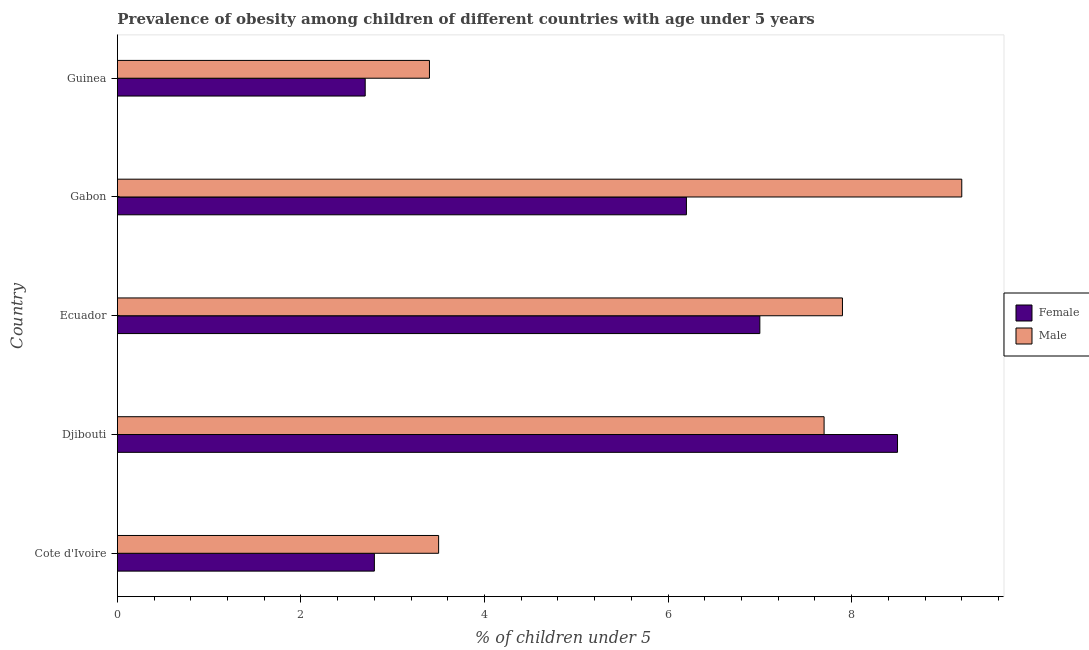How many groups of bars are there?
Give a very brief answer. 5. Are the number of bars on each tick of the Y-axis equal?
Offer a terse response. Yes. What is the label of the 1st group of bars from the top?
Provide a succinct answer. Guinea. In how many cases, is the number of bars for a given country not equal to the number of legend labels?
Your response must be concise. 0. What is the percentage of obese male children in Cote d'Ivoire?
Give a very brief answer. 3.5. Across all countries, what is the maximum percentage of obese male children?
Provide a short and direct response. 9.2. Across all countries, what is the minimum percentage of obese female children?
Offer a terse response. 2.7. In which country was the percentage of obese female children maximum?
Your answer should be compact. Djibouti. In which country was the percentage of obese male children minimum?
Make the answer very short. Guinea. What is the total percentage of obese female children in the graph?
Offer a terse response. 27.2. What is the difference between the percentage of obese male children in Guinea and the percentage of obese female children in Djibouti?
Offer a terse response. -5.1. What is the average percentage of obese male children per country?
Provide a succinct answer. 6.34. What is the difference between the percentage of obese male children and percentage of obese female children in Gabon?
Your response must be concise. 3. In how many countries, is the percentage of obese male children greater than 4.4 %?
Your response must be concise. 3. What is the ratio of the percentage of obese male children in Ecuador to that in Gabon?
Keep it short and to the point. 0.86. Is the percentage of obese female children in Cote d'Ivoire less than that in Djibouti?
Your answer should be compact. Yes. Is the difference between the percentage of obese female children in Djibouti and Gabon greater than the difference between the percentage of obese male children in Djibouti and Gabon?
Give a very brief answer. Yes. What is the difference between the highest and the second highest percentage of obese male children?
Your answer should be compact. 1.3. What is the difference between the highest and the lowest percentage of obese male children?
Provide a succinct answer. 5.8. In how many countries, is the percentage of obese male children greater than the average percentage of obese male children taken over all countries?
Ensure brevity in your answer.  3. Is the sum of the percentage of obese male children in Ecuador and Guinea greater than the maximum percentage of obese female children across all countries?
Offer a very short reply. Yes. What does the 2nd bar from the top in Djibouti represents?
Give a very brief answer. Female. How many bars are there?
Keep it short and to the point. 10. Are all the bars in the graph horizontal?
Offer a terse response. Yes. How many countries are there in the graph?
Offer a very short reply. 5. What is the difference between two consecutive major ticks on the X-axis?
Your answer should be very brief. 2. Does the graph contain grids?
Make the answer very short. No. How are the legend labels stacked?
Offer a very short reply. Vertical. What is the title of the graph?
Ensure brevity in your answer.  Prevalence of obesity among children of different countries with age under 5 years. What is the label or title of the X-axis?
Ensure brevity in your answer.   % of children under 5. What is the label or title of the Y-axis?
Give a very brief answer. Country. What is the  % of children under 5 of Female in Cote d'Ivoire?
Give a very brief answer. 2.8. What is the  % of children under 5 in Male in Cote d'Ivoire?
Keep it short and to the point. 3.5. What is the  % of children under 5 in Female in Djibouti?
Keep it short and to the point. 8.5. What is the  % of children under 5 of Male in Djibouti?
Your answer should be very brief. 7.7. What is the  % of children under 5 in Female in Ecuador?
Ensure brevity in your answer.  7. What is the  % of children under 5 in Male in Ecuador?
Give a very brief answer. 7.9. What is the  % of children under 5 in Female in Gabon?
Your answer should be very brief. 6.2. What is the  % of children under 5 in Male in Gabon?
Make the answer very short. 9.2. What is the  % of children under 5 in Female in Guinea?
Your answer should be compact. 2.7. What is the  % of children under 5 in Male in Guinea?
Offer a very short reply. 3.4. Across all countries, what is the maximum  % of children under 5 of Female?
Offer a very short reply. 8.5. Across all countries, what is the maximum  % of children under 5 in Male?
Give a very brief answer. 9.2. Across all countries, what is the minimum  % of children under 5 in Female?
Provide a short and direct response. 2.7. Across all countries, what is the minimum  % of children under 5 of Male?
Your response must be concise. 3.4. What is the total  % of children under 5 of Female in the graph?
Keep it short and to the point. 27.2. What is the total  % of children under 5 of Male in the graph?
Provide a succinct answer. 31.7. What is the difference between the  % of children under 5 of Female in Cote d'Ivoire and that in Djibouti?
Offer a very short reply. -5.7. What is the difference between the  % of children under 5 of Female in Cote d'Ivoire and that in Ecuador?
Your answer should be compact. -4.2. What is the difference between the  % of children under 5 of Male in Cote d'Ivoire and that in Ecuador?
Provide a short and direct response. -4.4. What is the difference between the  % of children under 5 of Female in Cote d'Ivoire and that in Gabon?
Ensure brevity in your answer.  -3.4. What is the difference between the  % of children under 5 of Male in Cote d'Ivoire and that in Gabon?
Give a very brief answer. -5.7. What is the difference between the  % of children under 5 in Female in Djibouti and that in Ecuador?
Offer a very short reply. 1.5. What is the difference between the  % of children under 5 of Male in Djibouti and that in Gabon?
Provide a succinct answer. -1.5. What is the difference between the  % of children under 5 of Male in Djibouti and that in Guinea?
Offer a very short reply. 4.3. What is the difference between the  % of children under 5 in Female in Ecuador and that in Gabon?
Ensure brevity in your answer.  0.8. What is the difference between the  % of children under 5 of Female in Ecuador and that in Guinea?
Your answer should be compact. 4.3. What is the difference between the  % of children under 5 in Female in Gabon and that in Guinea?
Your answer should be very brief. 3.5. What is the difference between the  % of children under 5 of Male in Gabon and that in Guinea?
Provide a succinct answer. 5.8. What is the difference between the  % of children under 5 in Female in Djibouti and the  % of children under 5 in Male in Ecuador?
Offer a very short reply. 0.6. What is the difference between the  % of children under 5 of Female in Djibouti and the  % of children under 5 of Male in Guinea?
Ensure brevity in your answer.  5.1. What is the average  % of children under 5 of Female per country?
Ensure brevity in your answer.  5.44. What is the average  % of children under 5 in Male per country?
Offer a very short reply. 6.34. What is the difference between the  % of children under 5 of Female and  % of children under 5 of Male in Djibouti?
Offer a terse response. 0.8. What is the difference between the  % of children under 5 of Female and  % of children under 5 of Male in Ecuador?
Offer a terse response. -0.9. What is the difference between the  % of children under 5 in Female and  % of children under 5 in Male in Gabon?
Provide a succinct answer. -3. What is the ratio of the  % of children under 5 in Female in Cote d'Ivoire to that in Djibouti?
Offer a very short reply. 0.33. What is the ratio of the  % of children under 5 of Male in Cote d'Ivoire to that in Djibouti?
Your response must be concise. 0.45. What is the ratio of the  % of children under 5 of Male in Cote d'Ivoire to that in Ecuador?
Give a very brief answer. 0.44. What is the ratio of the  % of children under 5 of Female in Cote d'Ivoire to that in Gabon?
Keep it short and to the point. 0.45. What is the ratio of the  % of children under 5 of Male in Cote d'Ivoire to that in Gabon?
Offer a very short reply. 0.38. What is the ratio of the  % of children under 5 in Male in Cote d'Ivoire to that in Guinea?
Your response must be concise. 1.03. What is the ratio of the  % of children under 5 of Female in Djibouti to that in Ecuador?
Provide a short and direct response. 1.21. What is the ratio of the  % of children under 5 of Male in Djibouti to that in Ecuador?
Give a very brief answer. 0.97. What is the ratio of the  % of children under 5 of Female in Djibouti to that in Gabon?
Keep it short and to the point. 1.37. What is the ratio of the  % of children under 5 of Male in Djibouti to that in Gabon?
Keep it short and to the point. 0.84. What is the ratio of the  % of children under 5 in Female in Djibouti to that in Guinea?
Ensure brevity in your answer.  3.15. What is the ratio of the  % of children under 5 of Male in Djibouti to that in Guinea?
Ensure brevity in your answer.  2.26. What is the ratio of the  % of children under 5 of Female in Ecuador to that in Gabon?
Ensure brevity in your answer.  1.13. What is the ratio of the  % of children under 5 in Male in Ecuador to that in Gabon?
Provide a succinct answer. 0.86. What is the ratio of the  % of children under 5 of Female in Ecuador to that in Guinea?
Make the answer very short. 2.59. What is the ratio of the  % of children under 5 of Male in Ecuador to that in Guinea?
Your answer should be very brief. 2.32. What is the ratio of the  % of children under 5 in Female in Gabon to that in Guinea?
Ensure brevity in your answer.  2.3. What is the ratio of the  % of children under 5 of Male in Gabon to that in Guinea?
Offer a terse response. 2.71. What is the difference between the highest and the lowest  % of children under 5 in Female?
Your response must be concise. 5.8. 